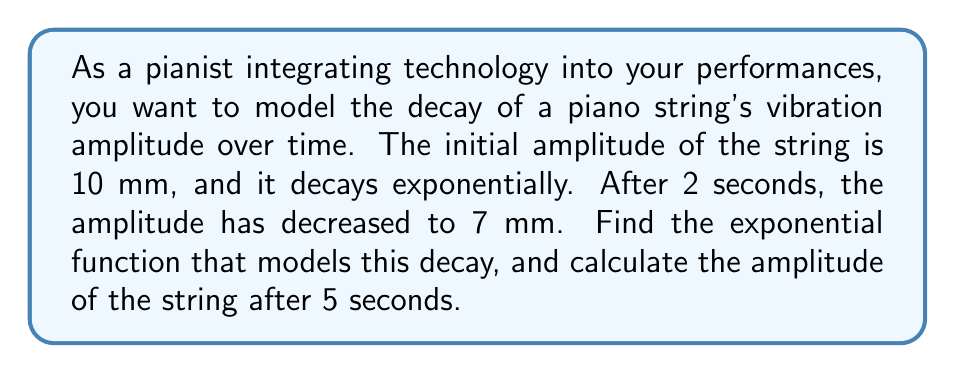Could you help me with this problem? Let's approach this step-by-step:

1) The general form of an exponential decay function is:

   $$A(t) = A_0 e^{-kt}$$

   where $A(t)$ is the amplitude at time $t$, $A_0$ is the initial amplitude, $k$ is the decay constant, and $t$ is time.

2) We know:
   - Initial amplitude $A_0 = 10$ mm
   - At $t = 2$ seconds, $A(2) = 7$ mm

3) Let's substitute these values into the equation:

   $$7 = 10 e^{-2k}$$

4) Divide both sides by 10:

   $$0.7 = e^{-2k}$$

5) Take the natural logarithm of both sides:

   $$\ln(0.7) = -2k$$

6) Solve for $k$:

   $$k = -\frac{\ln(0.7)}{2} \approx 0.1783$$

7) Now we have our complete model:

   $$A(t) = 10 e^{-0.1783t}$$

8) To find the amplitude after 5 seconds, we substitute $t = 5$ into our model:

   $$A(5) = 10 e^{-0.1783 \cdot 5} \approx 4.1$$

Therefore, after 5 seconds, the amplitude will be approximately 4.1 mm.
Answer: The exponential function modeling the decay is $A(t) = 10 e^{-0.1783t}$, where $A$ is in millimeters and $t$ is in seconds. The amplitude after 5 seconds is approximately 4.1 mm. 